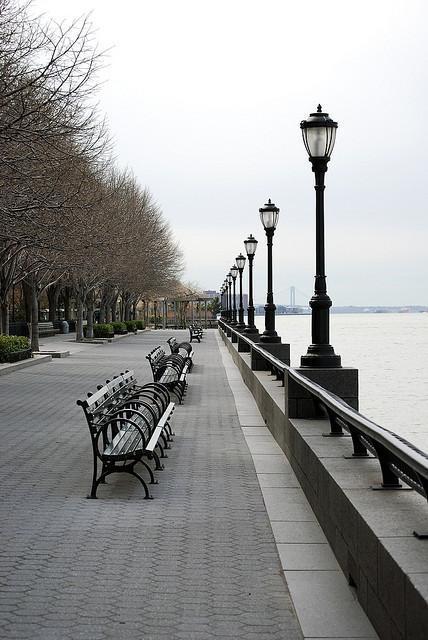How many benches are occupied?
Give a very brief answer. 0. How many kites are flying in the sky?
Give a very brief answer. 0. 